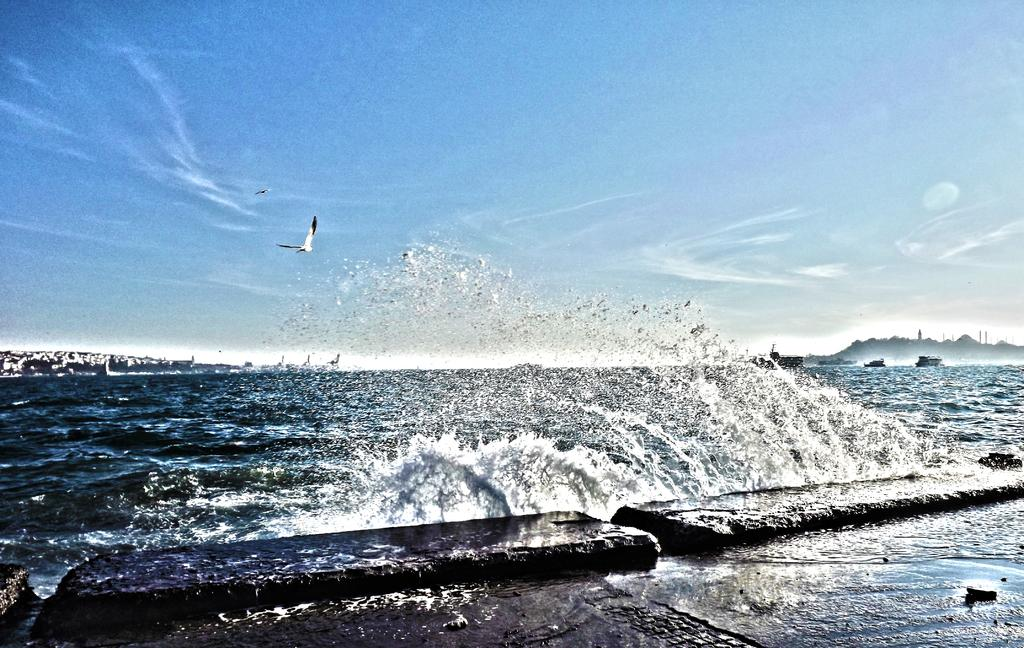What is the main subject of the image? The main subject of the image is a bird flying. Where is the bird located in the image? The bird is in the center of the image. What can be seen at the bottom of the image? There is water visible at the bottom of the image. What is visible at the top of the image? The sky is visible at the top of the image. What type of fear does the bird have in the image? There is no indication of fear in the image; the bird is simply flying. Can you tell me what the bird's dad looks like in the image? There is no mention of the bird's dad in the image, and no other birds are visible. 